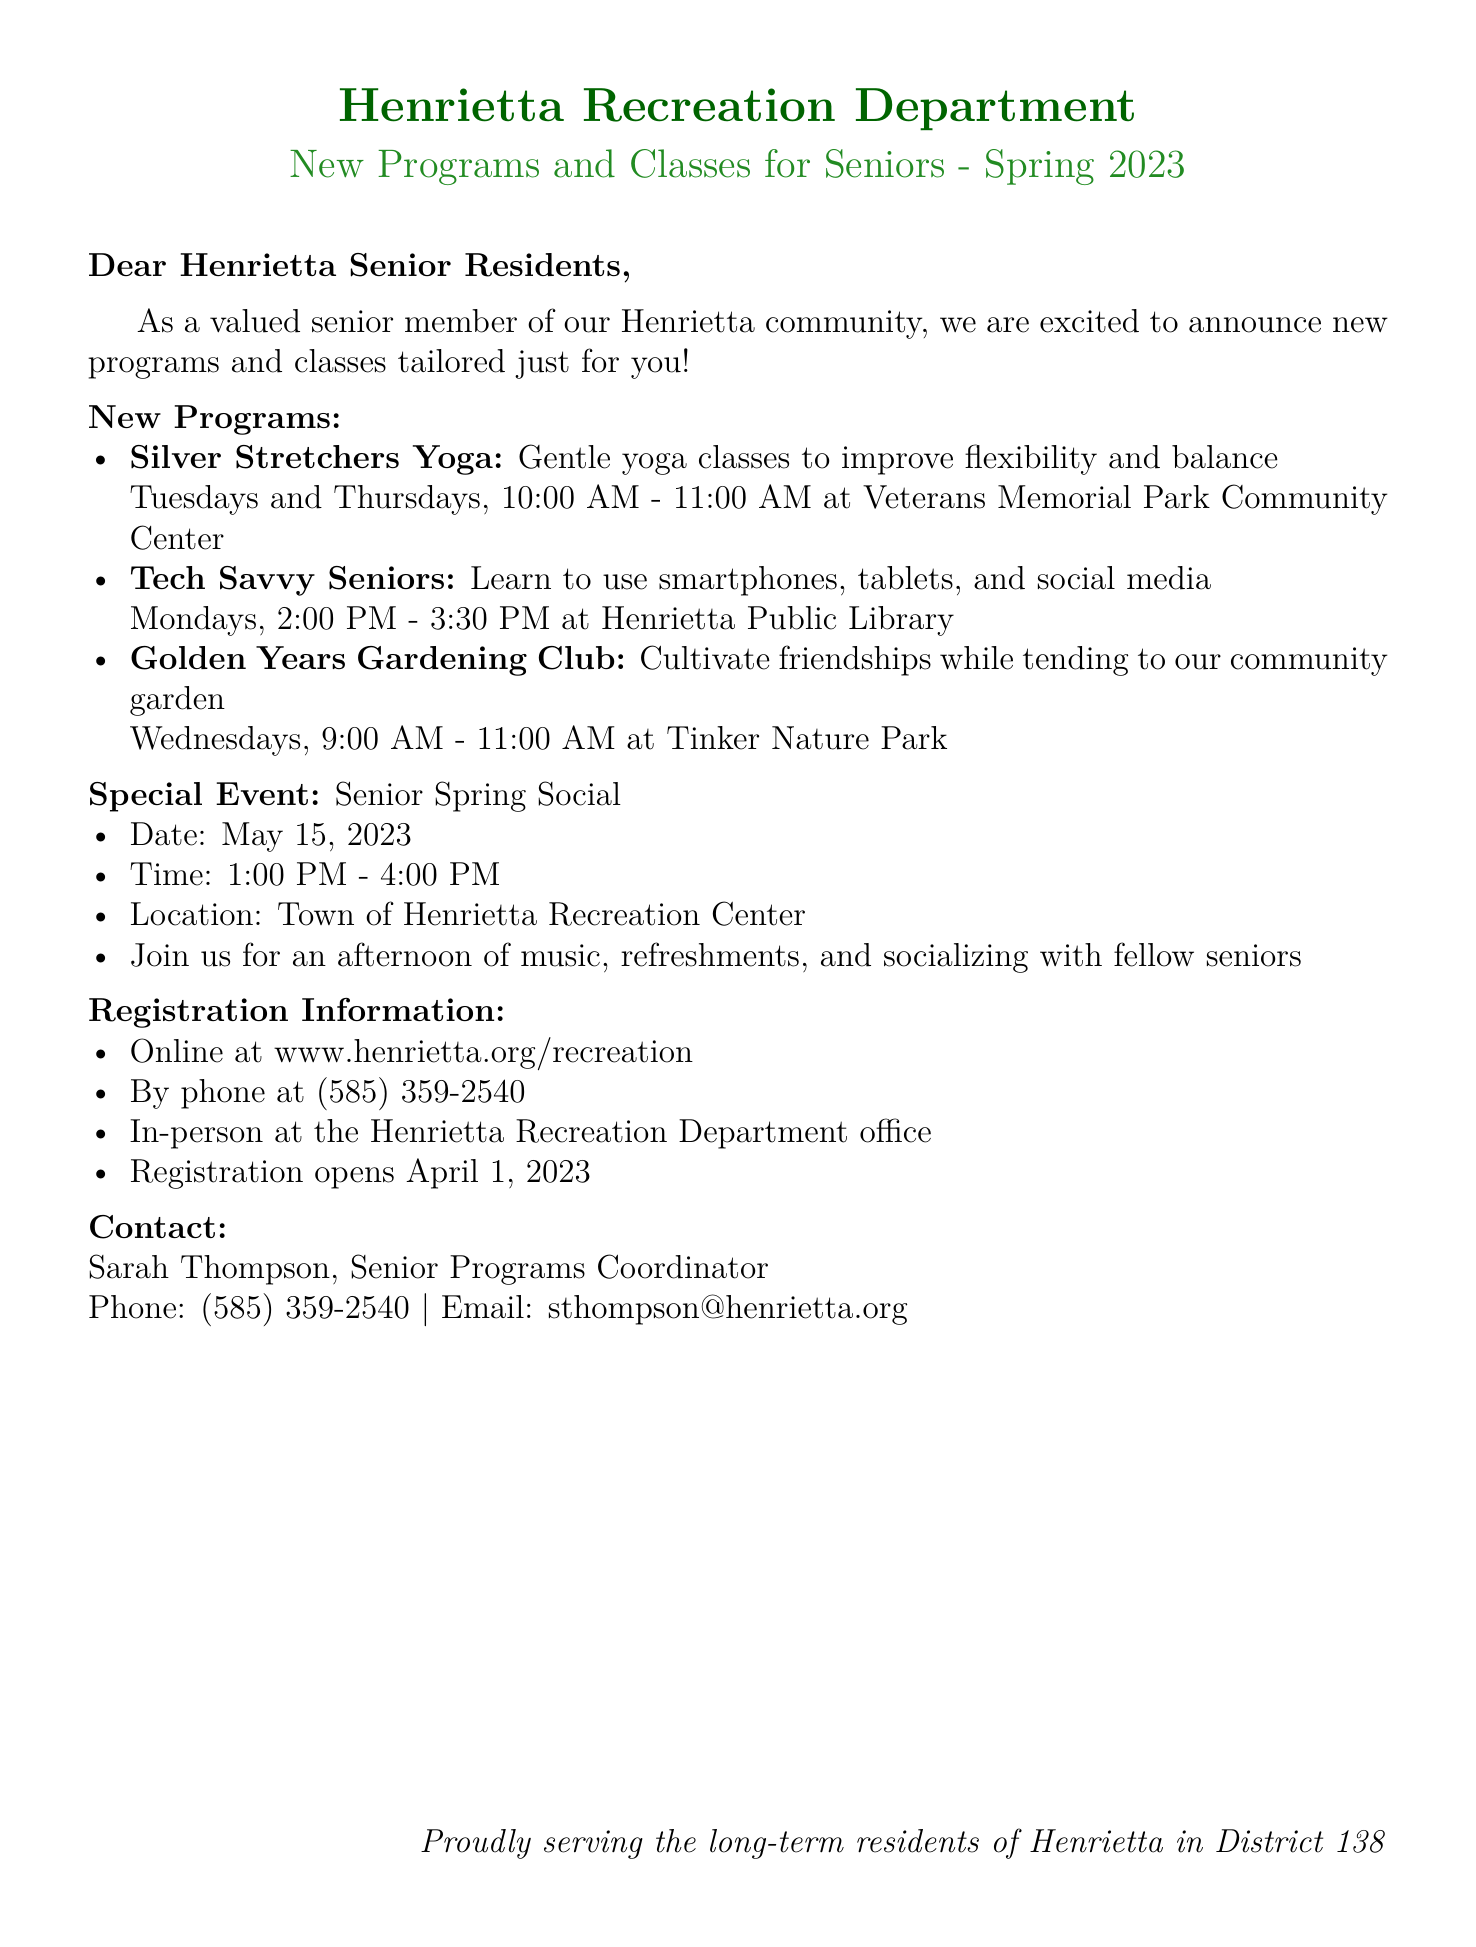What is the title of the yoga class? The title is specifically mentioned in the document under the new programs section.
Answer: Silver Stretchers Yoga When does the Tech Savvy Seniors class take place? The schedule for the class is clearly listed in the document.
Answer: Mondays, 2:00 PM - 3:30 PM What is the date of the Senior Spring Social? The date is mentioned in the special event section of the document.
Answer: May 15, 2023 Where is the Golden Years Gardening Club held? The location for this program is stated in the document.
Answer: Tinker Nature Park Who is the contact person for the senior programs? The document specifies the contact person for further inquiries.
Answer: Sarah Thompson What time does the Senior Spring Social start? The start time is provided in the special event details.
Answer: 1:00 PM When does registration open? This information is provided under the registration section of the document.
Answer: April 1, 2023 What is the location of the Tech Savvy Seniors class? The document clearly indicates where the class takes place.
Answer: Henrietta Public Library 